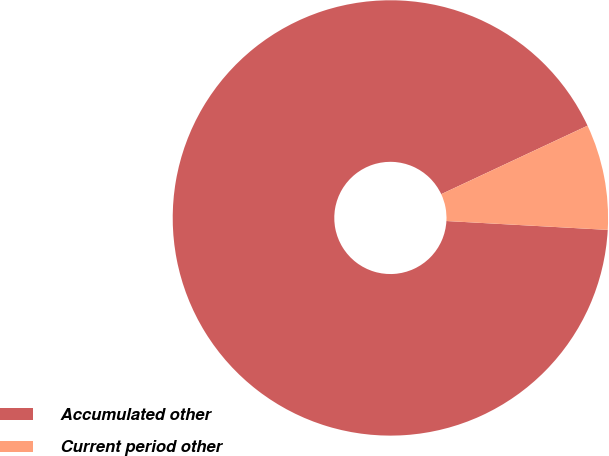Convert chart. <chart><loc_0><loc_0><loc_500><loc_500><pie_chart><fcel>Accumulated other<fcel>Current period other<nl><fcel>92.16%<fcel>7.84%<nl></chart> 